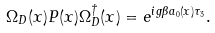<formula> <loc_0><loc_0><loc_500><loc_500>\Omega _ { D } ( x ) P ( x ) \Omega _ { D } ^ { \dagger } ( x ) = e ^ { i g \beta a _ { 0 } ( x ) \tau _ { 3 } } .</formula> 